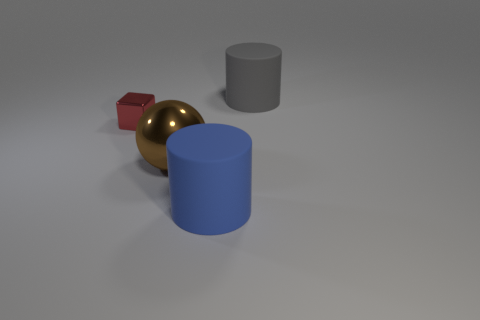Add 3 tiny yellow shiny objects. How many objects exist? 7 Subtract all balls. How many objects are left? 3 Add 1 gray things. How many gray things are left? 2 Add 1 red metal cubes. How many red metal cubes exist? 2 Subtract 0 yellow balls. How many objects are left? 4 Subtract all large gray matte cubes. Subtract all big matte cylinders. How many objects are left? 2 